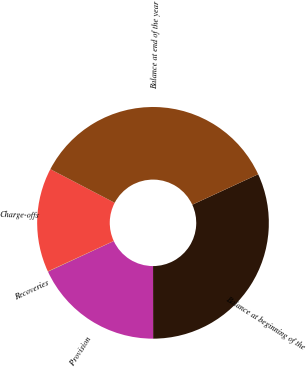Convert chart to OTSL. <chart><loc_0><loc_0><loc_500><loc_500><pie_chart><fcel>Balance at beginning of the<fcel>Provision<fcel>Recoveries<fcel>Charge-offs<fcel>Balance at end of the year<nl><fcel>31.87%<fcel>18.1%<fcel>0.03%<fcel>14.55%<fcel>35.45%<nl></chart> 